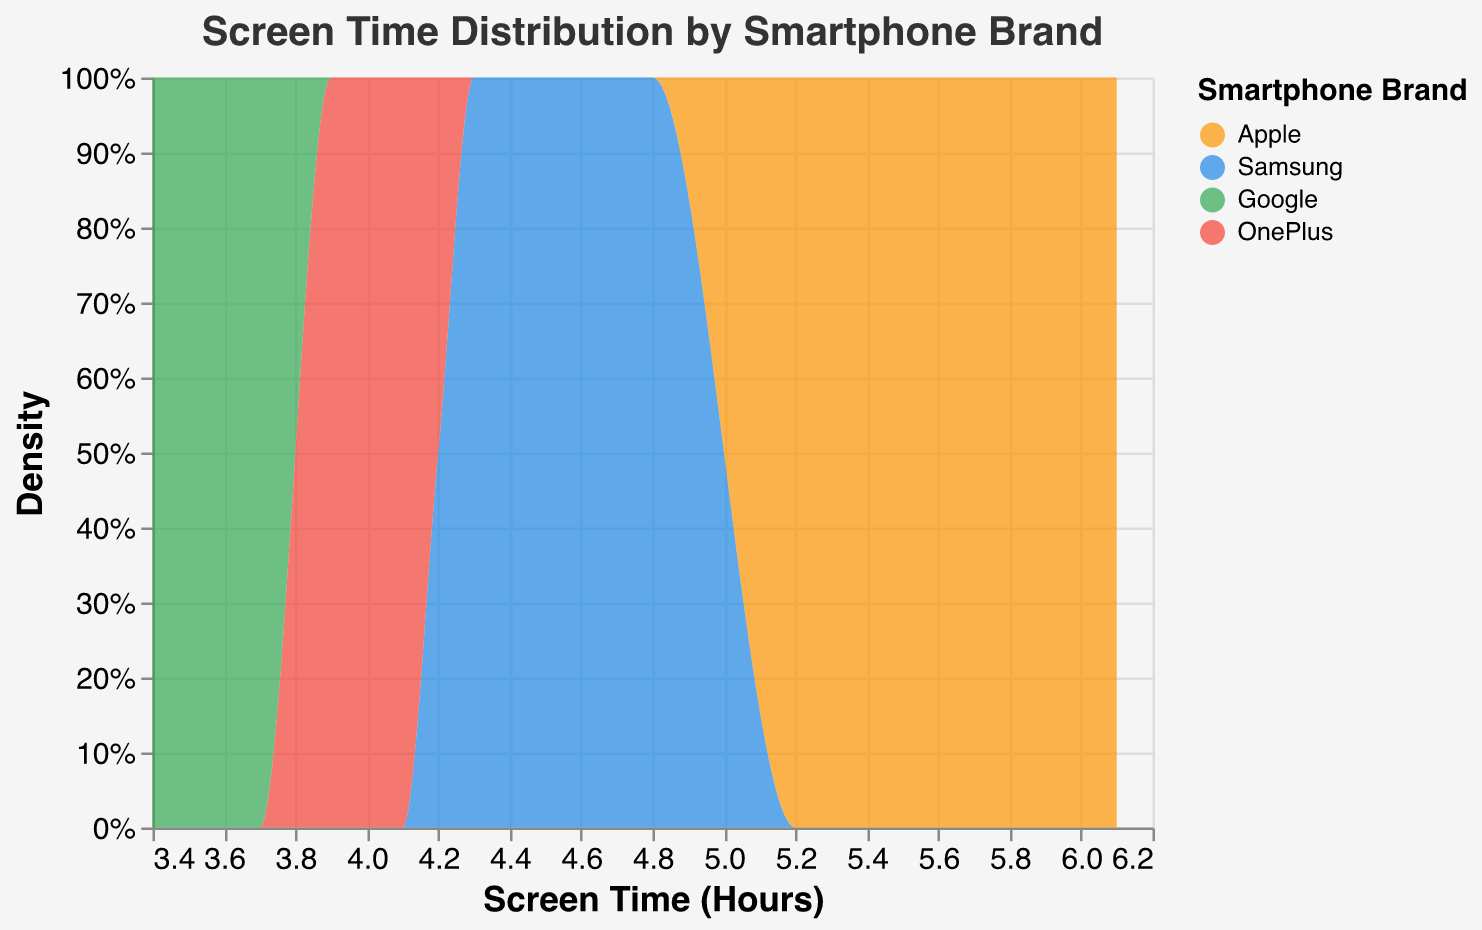What is the title of the figure? The title is usually found at the top of the figure and describes what the figure represents.
Answer: Screen Time Distribution by Smartphone Brand Which brand has the highest density in screen time usage? The highest density can be identified by the tallest peak in the density plot.
Answer: Apple What is the approximate screen time in hours where Apple has its highest density? The peak density for Apple can be seen at the highest point of the orange area under the curve.
Answer: Around 6 hours How does the screen time density of Samsung compare to OnePlus? Observe the curves for Samsung and OnePlus; compare their peak heights and distributions.
Answer: Samsung has slightly higher density For Apple, between what screen times in hours does most of its density lie? Observing the width of the curve for Apple can allow us to determine the range where the density is concentrated.
Answer: 5 to 6.5 hours Which brand has a lower density than Google at around 3.5 hours of screen time? Look for any curve that is shorter than Google's green curve at 3.5 hours.
Answer: Not applicable (Google has the lowest density at 3.5 hours) What is the screen time range where OnePlus shows significant density? Identify the range by looking at where the red curve is most prominently visible.
Answer: 3.8 to 4.3 hours Comparing Samsung and Google, which brand has a broader range of high-density screen time? Observe the width of the curves for both brands; Samsung's and Google's density ranges tell us which one has a broader range.
Answer: Samsung Which brand has the most consistent screen time distribution across its density? Consistency can be inferred by the even spread of the area under the curve.
Answer: OnePlus At around 5 hours of screen time, what are the density differences between Apple and Samsung? Compare the peaks for Apple and Samsung at the 5-hour mark; Apple seems higher visually.
Answer: Apple has higher density at 5 hours 